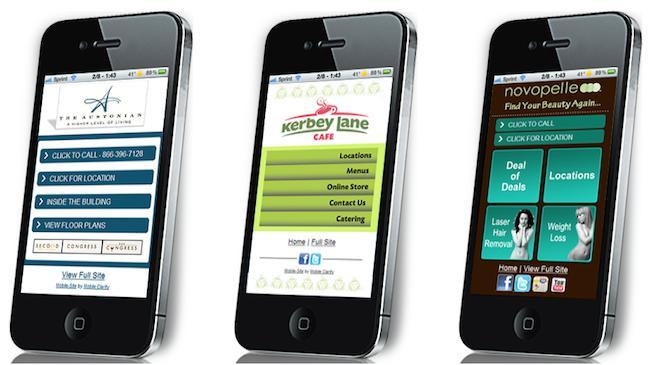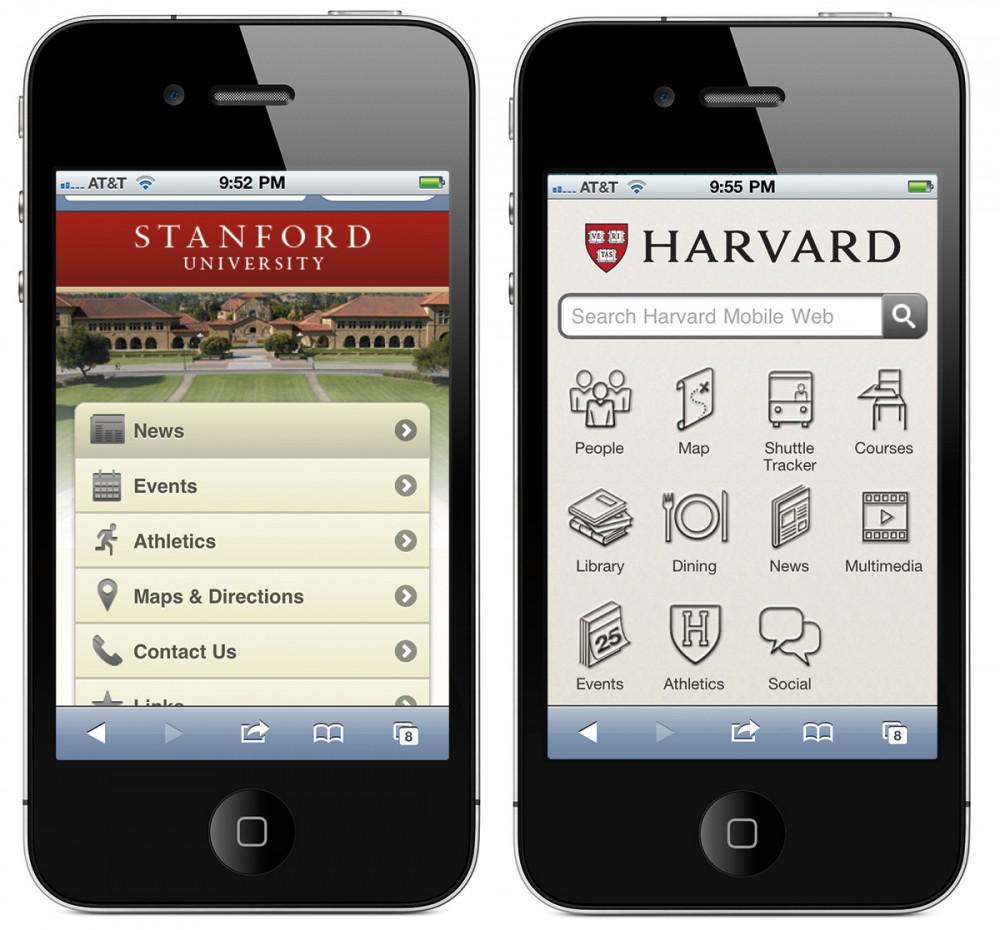The first image is the image on the left, the second image is the image on the right. For the images shown, is this caption "One image shows two side by side phones displayed screen-first and head-on, and the other image shows a row of three screen-first phones that are not overlapping." true? Answer yes or no. Yes. The first image is the image on the left, the second image is the image on the right. Assess this claim about the two images: "One of the images shows a cell phone that has three differently colored circles on the screen.". Correct or not? Answer yes or no. No. 